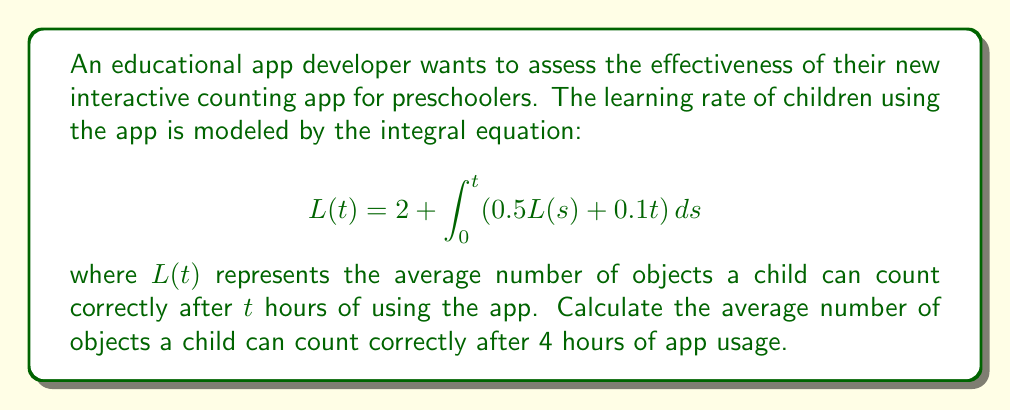Teach me how to tackle this problem. To solve this integral equation, we'll use the following steps:

1) First, we differentiate both sides of the equation with respect to $t$:

   $$\frac{d}{dt}L(t) = \frac{d}{dt}\left(2 + \int_0^t (0.5L(s) + 0.1t) ds\right)$$

2) Using the Fundamental Theorem of Calculus:

   $$L'(t) = 0.5L(t) + 0.1t$$

3) This is now a first-order linear differential equation. We can solve it using the integrating factor method. The integrating factor is:

   $$\mu(t) = e^{\int 0.5 dt} = e^{0.5t}$$

4) Multiplying both sides by $\mu(t)$:

   $$e^{0.5t}L'(t) + 0.5e^{0.5t}L(t) = 0.1te^{0.5t}$$

5) The left side is now the derivative of $e^{0.5t}L(t)$. So:

   $$\frac{d}{dt}(e^{0.5t}L(t)) = 0.1te^{0.5t}$$

6) Integrating both sides:

   $$e^{0.5t}L(t) = 0.1\int te^{0.5t}dt = 0.1\left(\frac{2t}{0.5}e^{0.5t} - \frac{2}{0.5^2}e^{0.5t}\right) + C$$

7) Simplifying and solving for $L(t)$:

   $$L(t) = 0.4te^{-0.5t} - 1.6e^{-0.5t} + Ce^{-0.5t}$$

8) Using the initial condition $L(0) = 2$, we find $C = 3.6$. So:

   $$L(t) = 0.4te^{-0.5t} - 1.6e^{-0.5t} + 3.6e^{-0.5t} = 0.4te^{-0.5t} + 2e^{-0.5t}$$

9) For $t = 4$:

   $$L(4) = 0.4(4)e^{-0.5(4)} + 2e^{-0.5(4)} = 1.6e^{-2} + 2e^{-2} = 3.6e^{-2} \approx 3.31$$

Therefore, after 4 hours of app usage, a child can count approximately 3.31 objects correctly on average.
Answer: 3.31 objects 